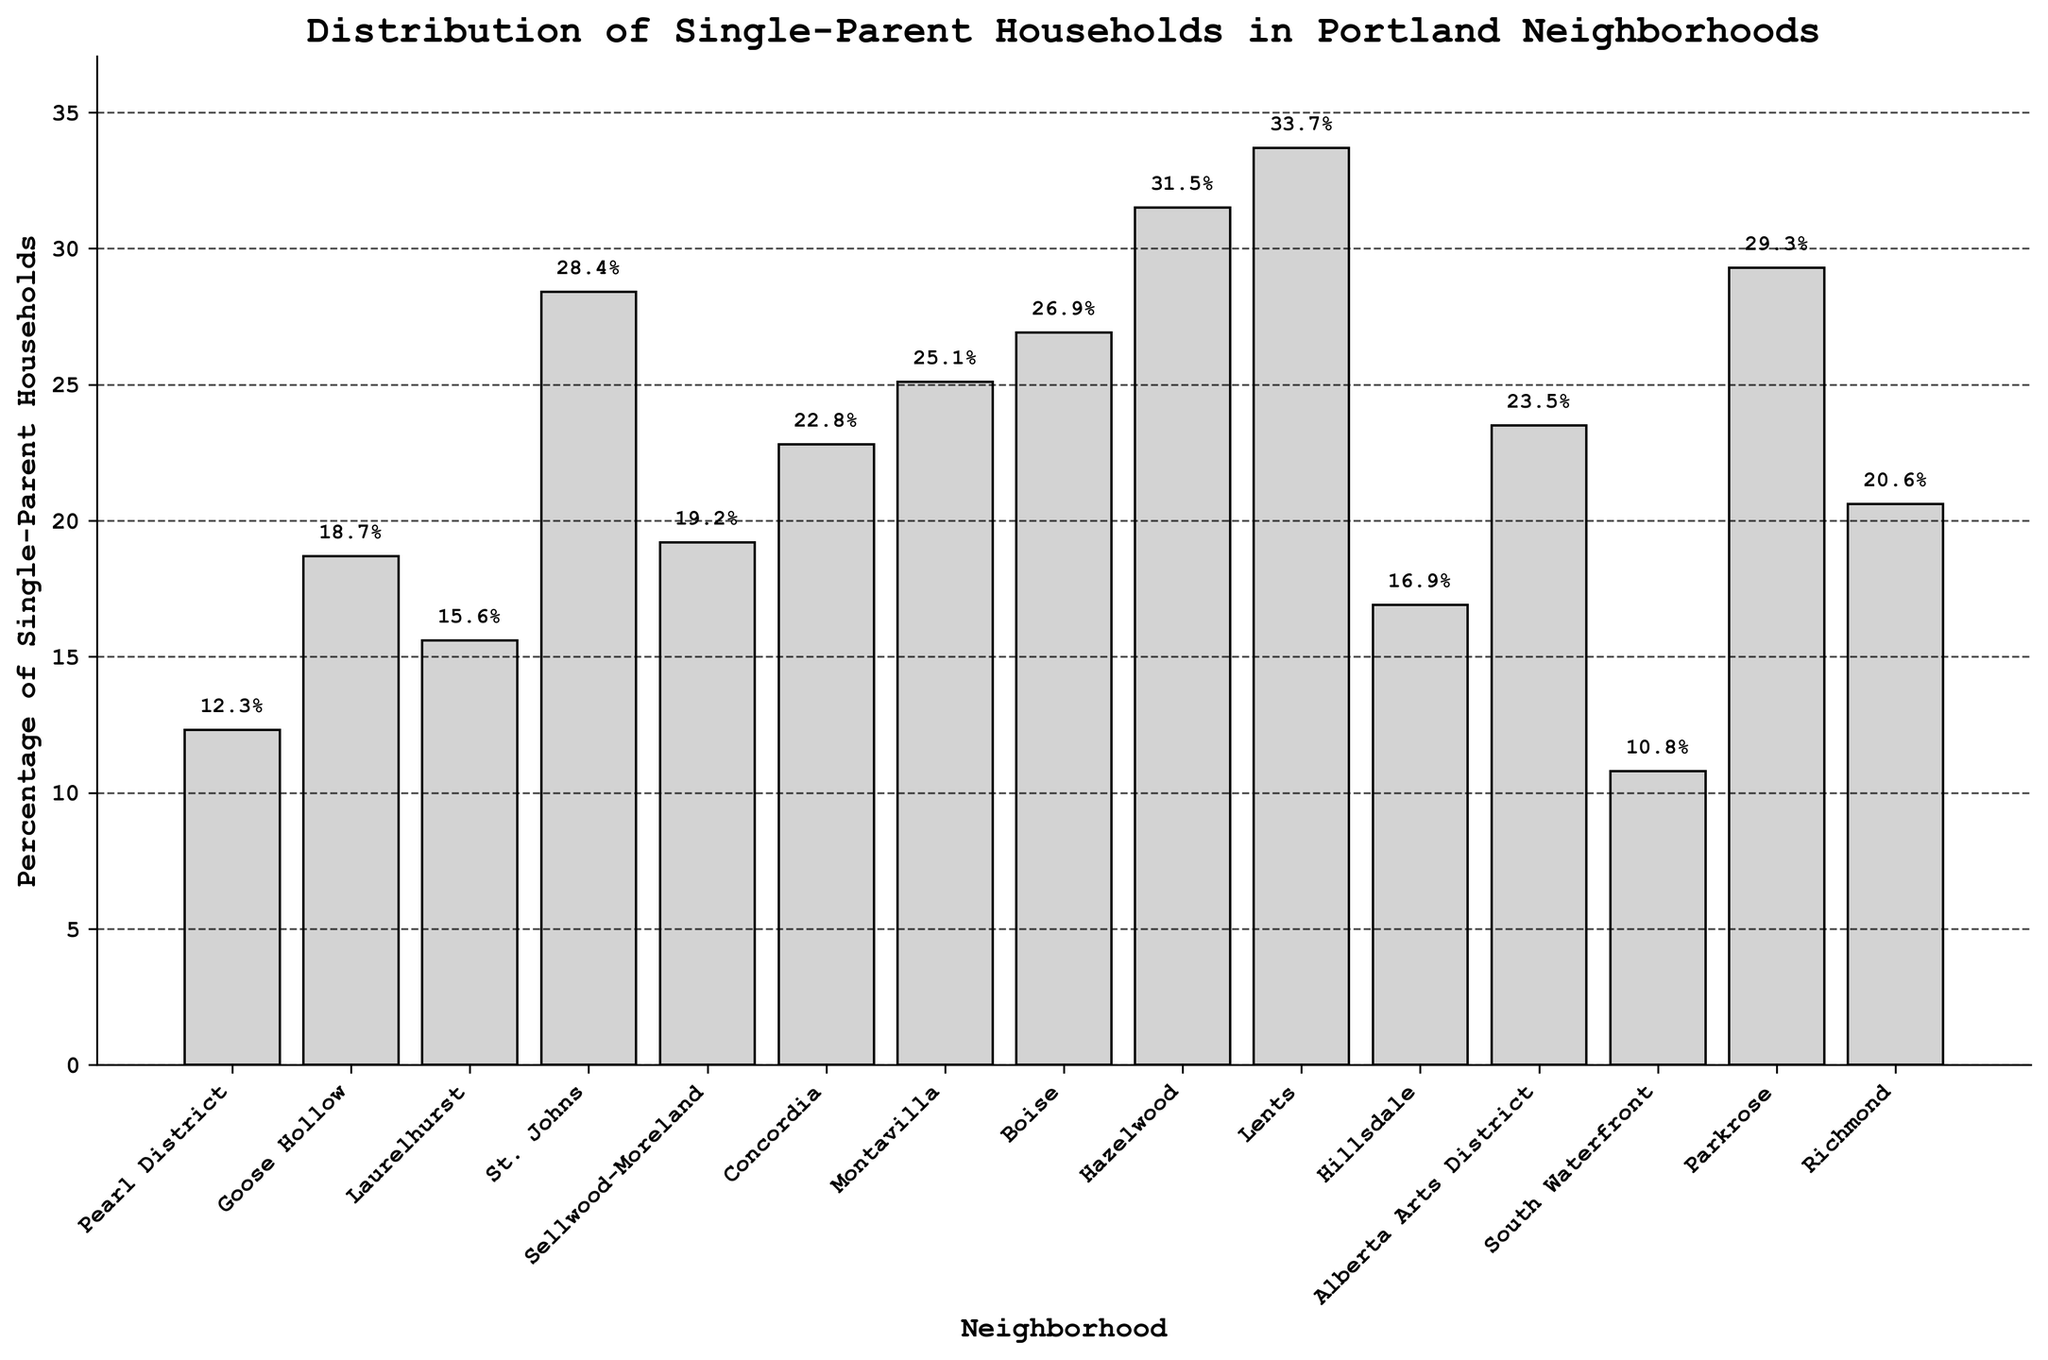Which neighborhood has the highest percentage of single-parent households? The highest bar in the chart represents the highest percentage. In this case, the tall bar at "Lents" shows 33.7%.
Answer: Lents Which neighborhood has the lowest percentage of single-parent households? The shortest bar in the chart represents the lowest percentage. The bar at "South Waterfront" shows 10.8%.
Answer: South Waterfront How many neighborhoods have a percentage of single-parent households higher than 25%? By visually inspecting the bars, we see that "St. Johns", "Boise", "Hazelwood", "Lents", "Alberta Arts District", and "Parkrose" have bars higher than 25%. Counting these, we get six neighborhoods.
Answer: 6 What is the difference in the percentage of single-parent households between Hazelwood and Richmond? The bar for Hazelwood shows 31.5%, and Richmond shows 20.6%. The difference is calculated as 31.5% - 20.6% = 10.9%.
Answer: 10.9% What is the average percentage of single-parent households for the neighborhoods of Concordia, Montavilla, and Boise? The percentages for Concordia, Montavilla, and Boise are 22.8%, 25.1%, and 26.9% respectively. Adding them together we get 22.8 + 25.1 + 26.9 = 74.8. Dividing by the number of neighborhoods (3) gives 74.8 / 3 = 24.933%.
Answer: 24.933% How does the percentage of single-parent households in Pearl District compare to Goose Hollow? The bar for Pearl District shows 12.3% and Goose Hollow shows 18.7%, indicating that Goose Hollow has a higher percentage than Pearl District.
Answer: Goose Hollow is higher What is the median percentage of single-parent households among all neighborhoods listed? To find the median, list the percentages in order: 10.8, 12.3, 15.6, 16.9, 18.7, 19.2, 20.6, 22.8, 23.5, 25.1, 26.9, 28.4, 29.3, 31.5, 33.7. The middle value (8th) in this ordered list is 22.8%.
Answer: 22.8% How many neighborhoods have a percentage of single-parent households between 20% and 30%? Count the neighborhoods where the bars fall in the range of 20% to 30%. These are Richmond, Concordia, Alberta Arts District, Montavilla, Boise, St. Johns, and Parkrose, totaling seven neighborhoods.
Answer: 7 Compare the percentage of single-parent households in Hillsdale and Laurelhurst, and determine which one is higher and by how much. Hillsdale has 16.9%, whereas Laurelhurst has 15.6%. Hillsdale is higher by 16.9% - 15.6% = 1.3%.
Answer: Hillsdale is higher by 1.3% 